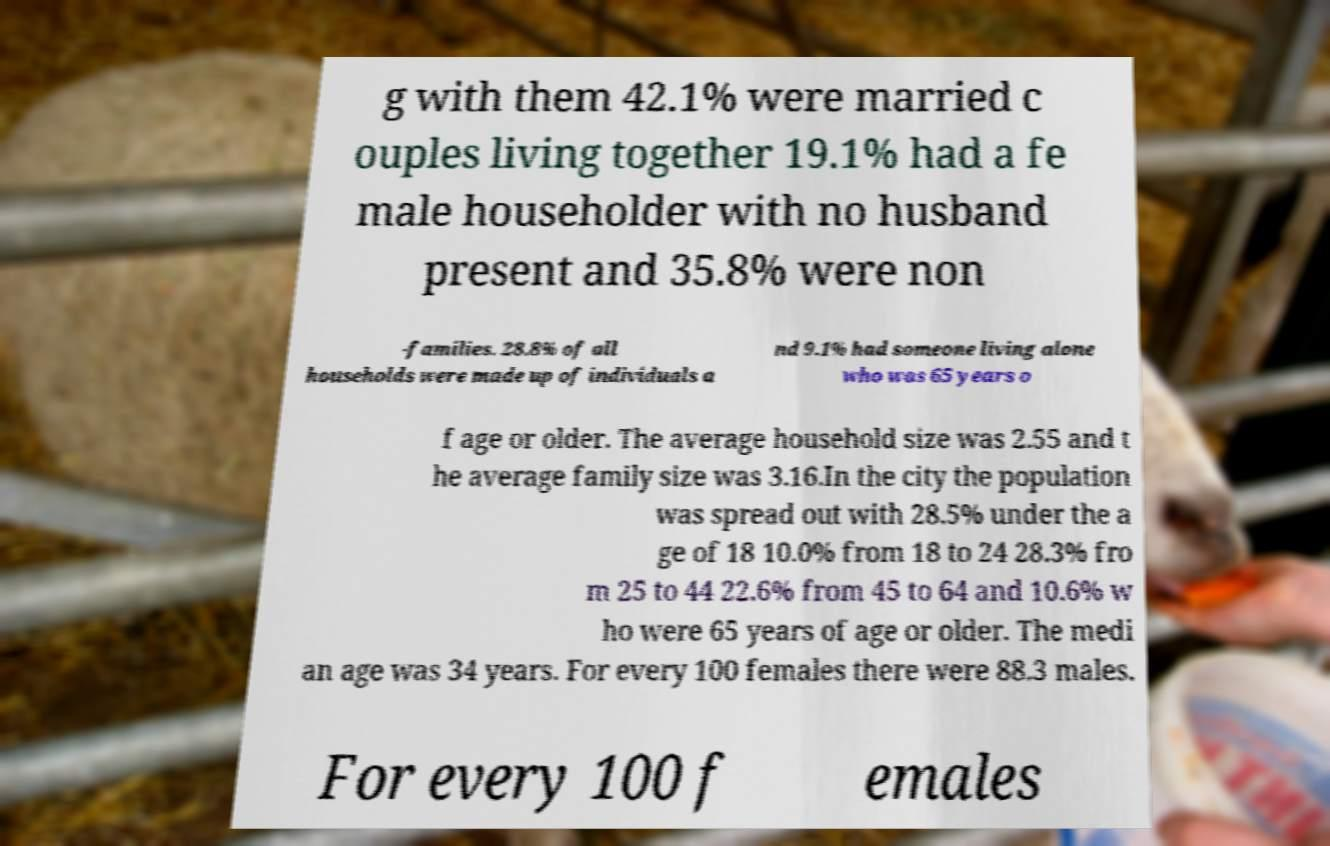Please read and relay the text visible in this image. What does it say? g with them 42.1% were married c ouples living together 19.1% had a fe male householder with no husband present and 35.8% were non -families. 28.8% of all households were made up of individuals a nd 9.1% had someone living alone who was 65 years o f age or older. The average household size was 2.55 and t he average family size was 3.16.In the city the population was spread out with 28.5% under the a ge of 18 10.0% from 18 to 24 28.3% fro m 25 to 44 22.6% from 45 to 64 and 10.6% w ho were 65 years of age or older. The medi an age was 34 years. For every 100 females there were 88.3 males. For every 100 f emales 